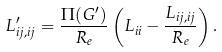<formula> <loc_0><loc_0><loc_500><loc_500>L ^ { \prime } _ { i j , i j } = \frac { \Pi ( G ^ { \prime } ) } { R _ { e } } \left ( L _ { i i } - \frac { L _ { i j , i j } } { R _ { e } } \right ) .</formula> 